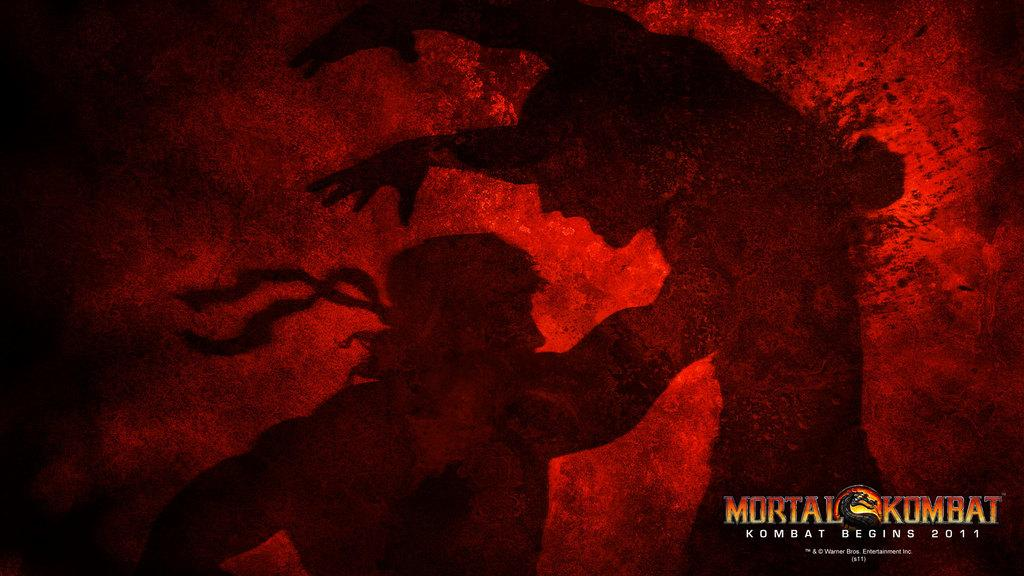Provide a one-sentence caption for the provided image. Poster showing two men fighting and the words "Mortal Komat" on the bottom right. 